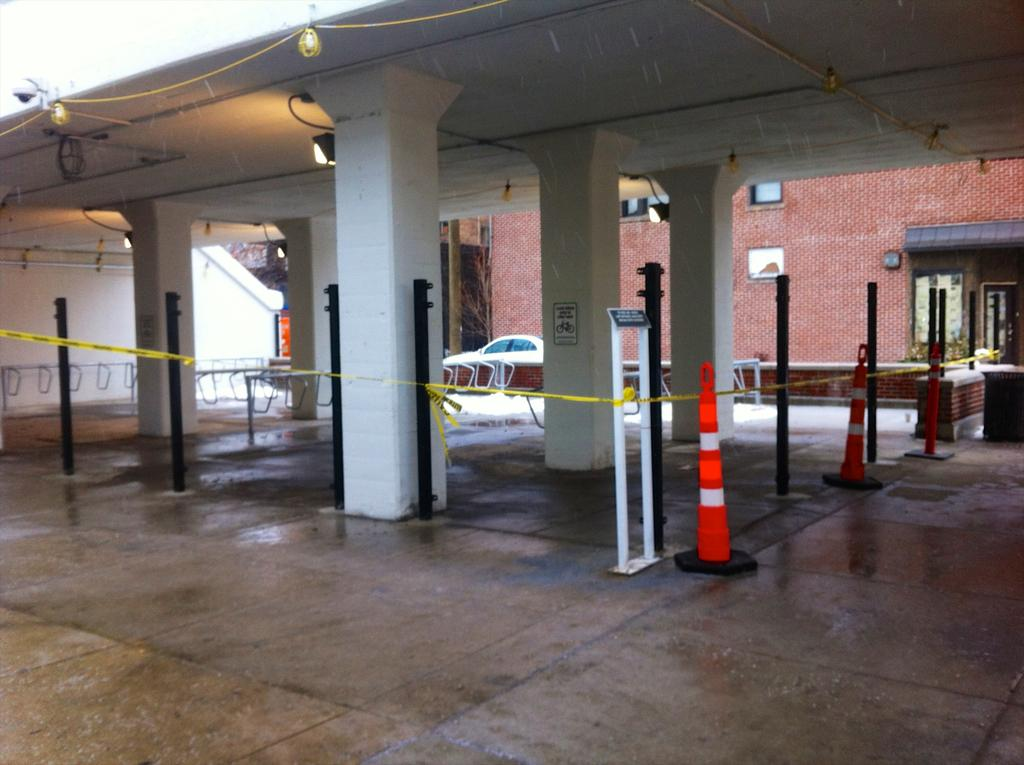What is the main subject of the image? There is a vehicle in the image. What other objects can be seen in the image? There is a road cone, pillars, a light, a building, a floor, and poles in the image. Can you describe the light in the image? There is a light in the image, but its specific type or function is not mentioned. What type of structure is depicted in the image? There is a building in the image, but its specific design or purpose is not mentioned. What type of cap can be seen on the seed in the image? There is no cap or seed present in the image. How does the fog affect the visibility of the poles in the image? There is no fog present in the image, so its effect on visibility cannot be determined. 